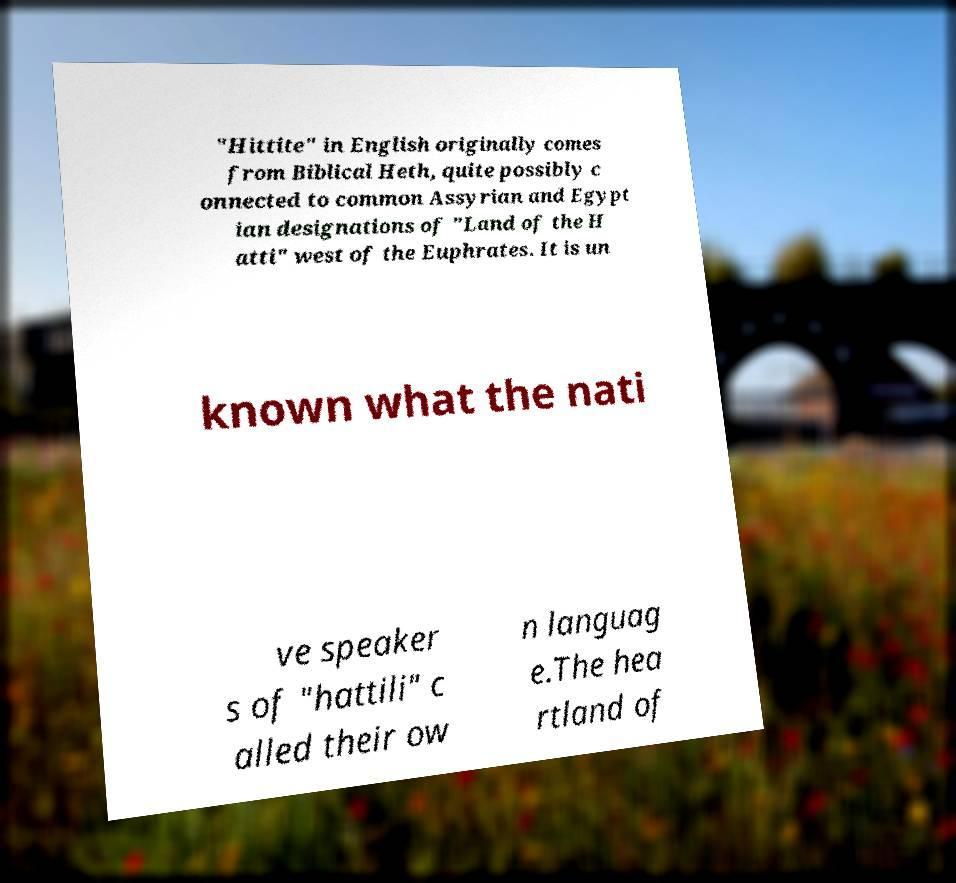There's text embedded in this image that I need extracted. Can you transcribe it verbatim? "Hittite" in English originally comes from Biblical Heth, quite possibly c onnected to common Assyrian and Egypt ian designations of "Land of the H atti" west of the Euphrates. It is un known what the nati ve speaker s of "hattili" c alled their ow n languag e.The hea rtland of 